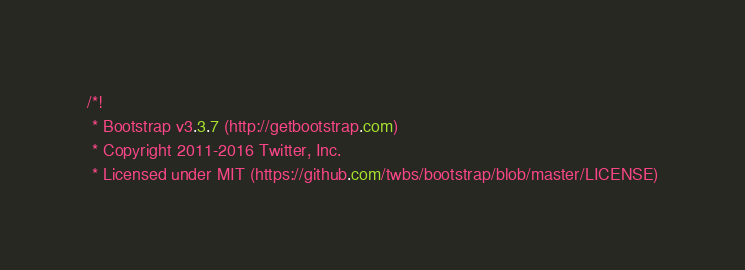<code> <loc_0><loc_0><loc_500><loc_500><_CSS_>/*!
 * Bootstrap v3.3.7 (http://getbootstrap.com)
 * Copyright 2011-2016 Twitter, Inc.
 * Licensed under MIT (https://github.com/twbs/bootstrap/blob/master/LICENSE)</code> 